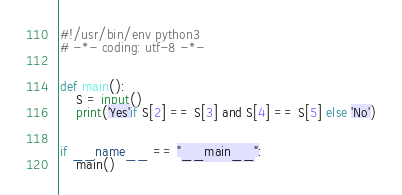Convert code to text. <code><loc_0><loc_0><loc_500><loc_500><_Python_>#!/usr/bin/env python3
# -*- coding: utf-8 -*-


def main():
    S = input()
    print('Yes'if S[2] == S[3] and S[4] == S[5] else 'No')


if __name__ == "__main__":
    main()
</code> 